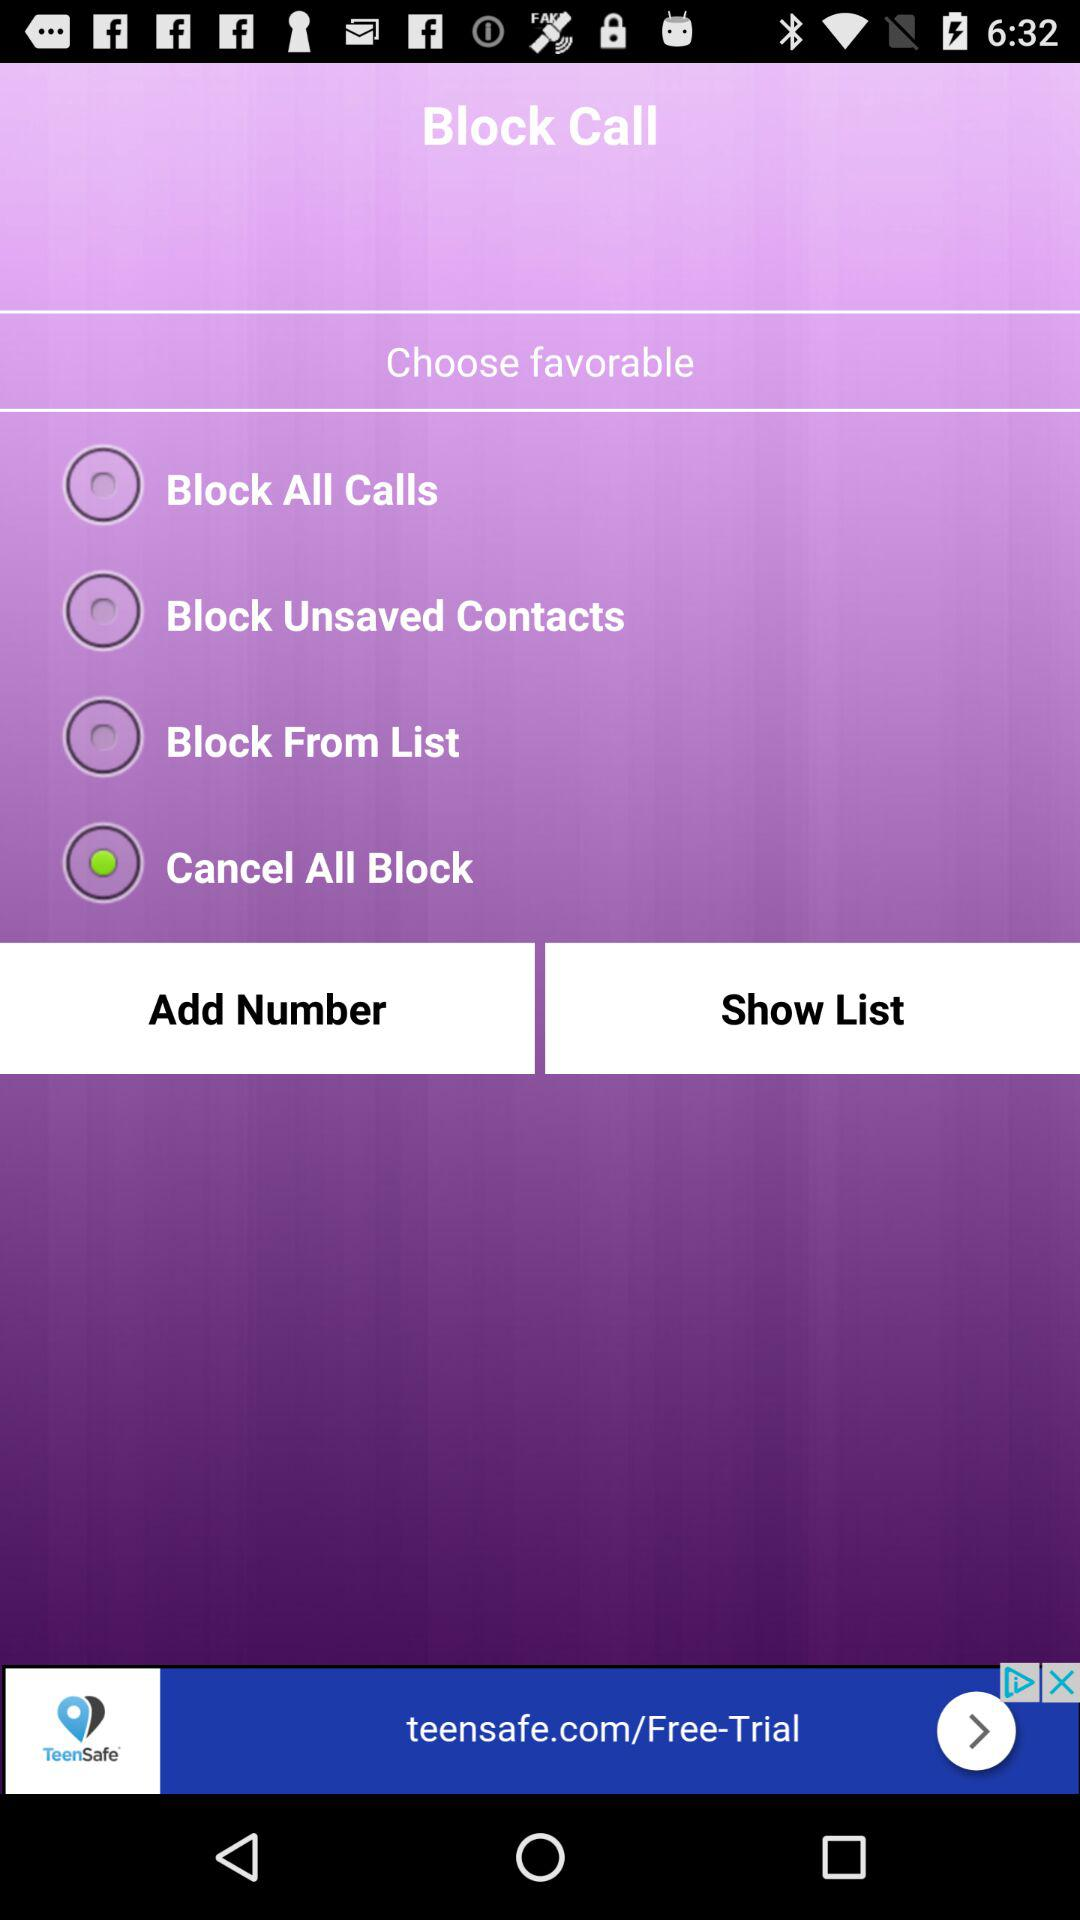Which option is selected? The selected option is "Cancel All Block". 